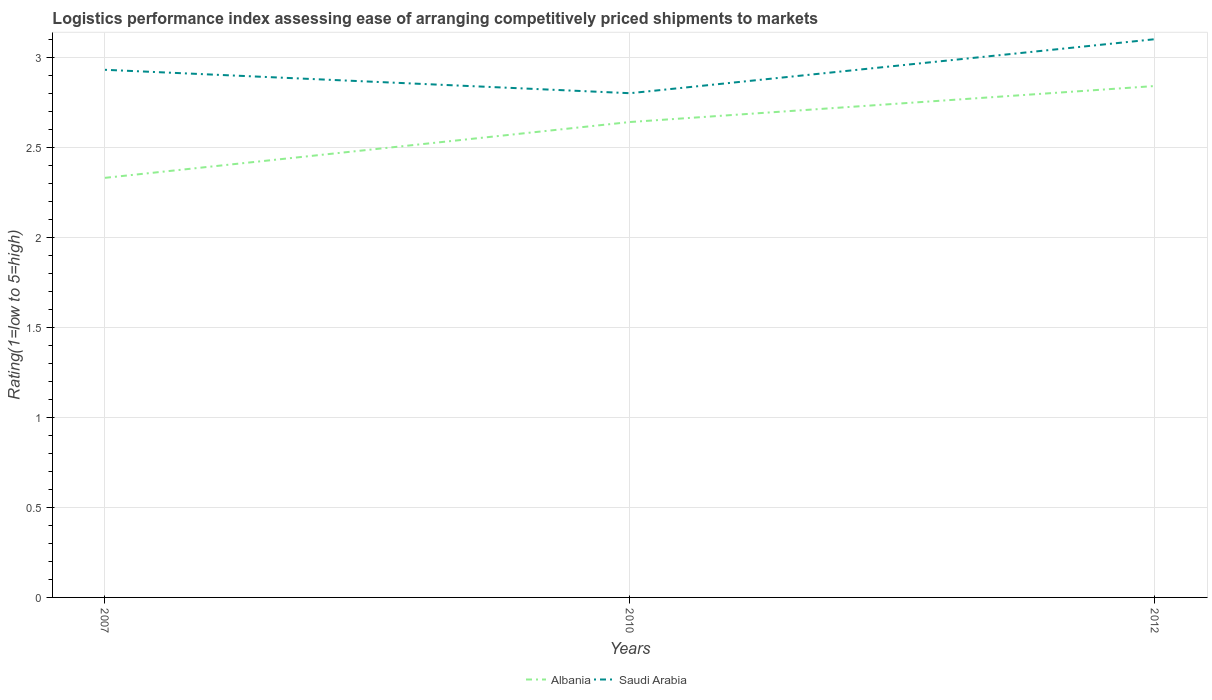How many different coloured lines are there?
Offer a terse response. 2. Does the line corresponding to Albania intersect with the line corresponding to Saudi Arabia?
Keep it short and to the point. No. Across all years, what is the maximum Logistic performance index in Albania?
Ensure brevity in your answer.  2.33. In which year was the Logistic performance index in Saudi Arabia maximum?
Make the answer very short. 2010. What is the total Logistic performance index in Saudi Arabia in the graph?
Your response must be concise. -0.17. What is the difference between the highest and the second highest Logistic performance index in Albania?
Provide a succinct answer. 0.51. What is the difference between the highest and the lowest Logistic performance index in Albania?
Offer a very short reply. 2. Is the Logistic performance index in Saudi Arabia strictly greater than the Logistic performance index in Albania over the years?
Provide a succinct answer. No. How many years are there in the graph?
Offer a terse response. 3. What is the difference between two consecutive major ticks on the Y-axis?
Provide a short and direct response. 0.5. Does the graph contain any zero values?
Your response must be concise. No. Where does the legend appear in the graph?
Make the answer very short. Bottom center. How many legend labels are there?
Ensure brevity in your answer.  2. What is the title of the graph?
Ensure brevity in your answer.  Logistics performance index assessing ease of arranging competitively priced shipments to markets. Does "West Bank and Gaza" appear as one of the legend labels in the graph?
Offer a terse response. No. What is the label or title of the Y-axis?
Make the answer very short. Rating(1=low to 5=high). What is the Rating(1=low to 5=high) of Albania in 2007?
Make the answer very short. 2.33. What is the Rating(1=low to 5=high) of Saudi Arabia in 2007?
Your answer should be compact. 2.93. What is the Rating(1=low to 5=high) in Albania in 2010?
Make the answer very short. 2.64. What is the Rating(1=low to 5=high) of Saudi Arabia in 2010?
Ensure brevity in your answer.  2.8. What is the Rating(1=low to 5=high) in Albania in 2012?
Your answer should be very brief. 2.84. Across all years, what is the maximum Rating(1=low to 5=high) in Albania?
Your answer should be very brief. 2.84. Across all years, what is the maximum Rating(1=low to 5=high) in Saudi Arabia?
Provide a short and direct response. 3.1. Across all years, what is the minimum Rating(1=low to 5=high) in Albania?
Offer a very short reply. 2.33. Across all years, what is the minimum Rating(1=low to 5=high) of Saudi Arabia?
Your response must be concise. 2.8. What is the total Rating(1=low to 5=high) of Albania in the graph?
Give a very brief answer. 7.81. What is the total Rating(1=low to 5=high) of Saudi Arabia in the graph?
Offer a very short reply. 8.83. What is the difference between the Rating(1=low to 5=high) of Albania in 2007 and that in 2010?
Provide a succinct answer. -0.31. What is the difference between the Rating(1=low to 5=high) in Saudi Arabia in 2007 and that in 2010?
Make the answer very short. 0.13. What is the difference between the Rating(1=low to 5=high) in Albania in 2007 and that in 2012?
Keep it short and to the point. -0.51. What is the difference between the Rating(1=low to 5=high) of Saudi Arabia in 2007 and that in 2012?
Keep it short and to the point. -0.17. What is the difference between the Rating(1=low to 5=high) in Albania in 2010 and that in 2012?
Keep it short and to the point. -0.2. What is the difference between the Rating(1=low to 5=high) of Albania in 2007 and the Rating(1=low to 5=high) of Saudi Arabia in 2010?
Your response must be concise. -0.47. What is the difference between the Rating(1=low to 5=high) of Albania in 2007 and the Rating(1=low to 5=high) of Saudi Arabia in 2012?
Provide a succinct answer. -0.77. What is the difference between the Rating(1=low to 5=high) in Albania in 2010 and the Rating(1=low to 5=high) in Saudi Arabia in 2012?
Keep it short and to the point. -0.46. What is the average Rating(1=low to 5=high) in Albania per year?
Offer a very short reply. 2.6. What is the average Rating(1=low to 5=high) in Saudi Arabia per year?
Your answer should be compact. 2.94. In the year 2007, what is the difference between the Rating(1=low to 5=high) in Albania and Rating(1=low to 5=high) in Saudi Arabia?
Provide a succinct answer. -0.6. In the year 2010, what is the difference between the Rating(1=low to 5=high) in Albania and Rating(1=low to 5=high) in Saudi Arabia?
Give a very brief answer. -0.16. In the year 2012, what is the difference between the Rating(1=low to 5=high) in Albania and Rating(1=low to 5=high) in Saudi Arabia?
Ensure brevity in your answer.  -0.26. What is the ratio of the Rating(1=low to 5=high) in Albania in 2007 to that in 2010?
Offer a terse response. 0.88. What is the ratio of the Rating(1=low to 5=high) of Saudi Arabia in 2007 to that in 2010?
Make the answer very short. 1.05. What is the ratio of the Rating(1=low to 5=high) of Albania in 2007 to that in 2012?
Your answer should be compact. 0.82. What is the ratio of the Rating(1=low to 5=high) in Saudi Arabia in 2007 to that in 2012?
Your response must be concise. 0.95. What is the ratio of the Rating(1=low to 5=high) in Albania in 2010 to that in 2012?
Offer a very short reply. 0.93. What is the ratio of the Rating(1=low to 5=high) of Saudi Arabia in 2010 to that in 2012?
Offer a very short reply. 0.9. What is the difference between the highest and the second highest Rating(1=low to 5=high) of Albania?
Your answer should be very brief. 0.2. What is the difference between the highest and the second highest Rating(1=low to 5=high) in Saudi Arabia?
Keep it short and to the point. 0.17. What is the difference between the highest and the lowest Rating(1=low to 5=high) in Albania?
Offer a very short reply. 0.51. 